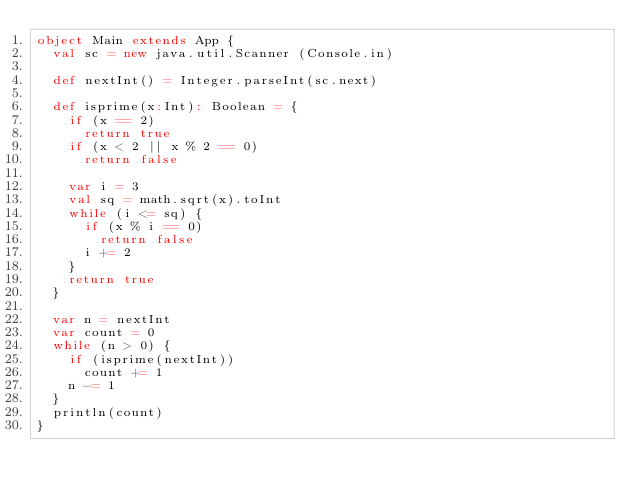Convert code to text. <code><loc_0><loc_0><loc_500><loc_500><_Scala_>object Main extends App {
  val sc = new java.util.Scanner (Console.in)

  def nextInt() = Integer.parseInt(sc.next)

  def isprime(x:Int): Boolean = {
    if (x == 2)
      return true
    if (x < 2 || x % 2 == 0)
      return false

    var i = 3
    val sq = math.sqrt(x).toInt
    while (i <= sq) {
      if (x % i == 0)
        return false
      i += 2
    }
    return true
  }

  var n = nextInt
  var count = 0
  while (n > 0) {
    if (isprime(nextInt))
      count += 1
    n -= 1
  }
  println(count)
}

</code> 